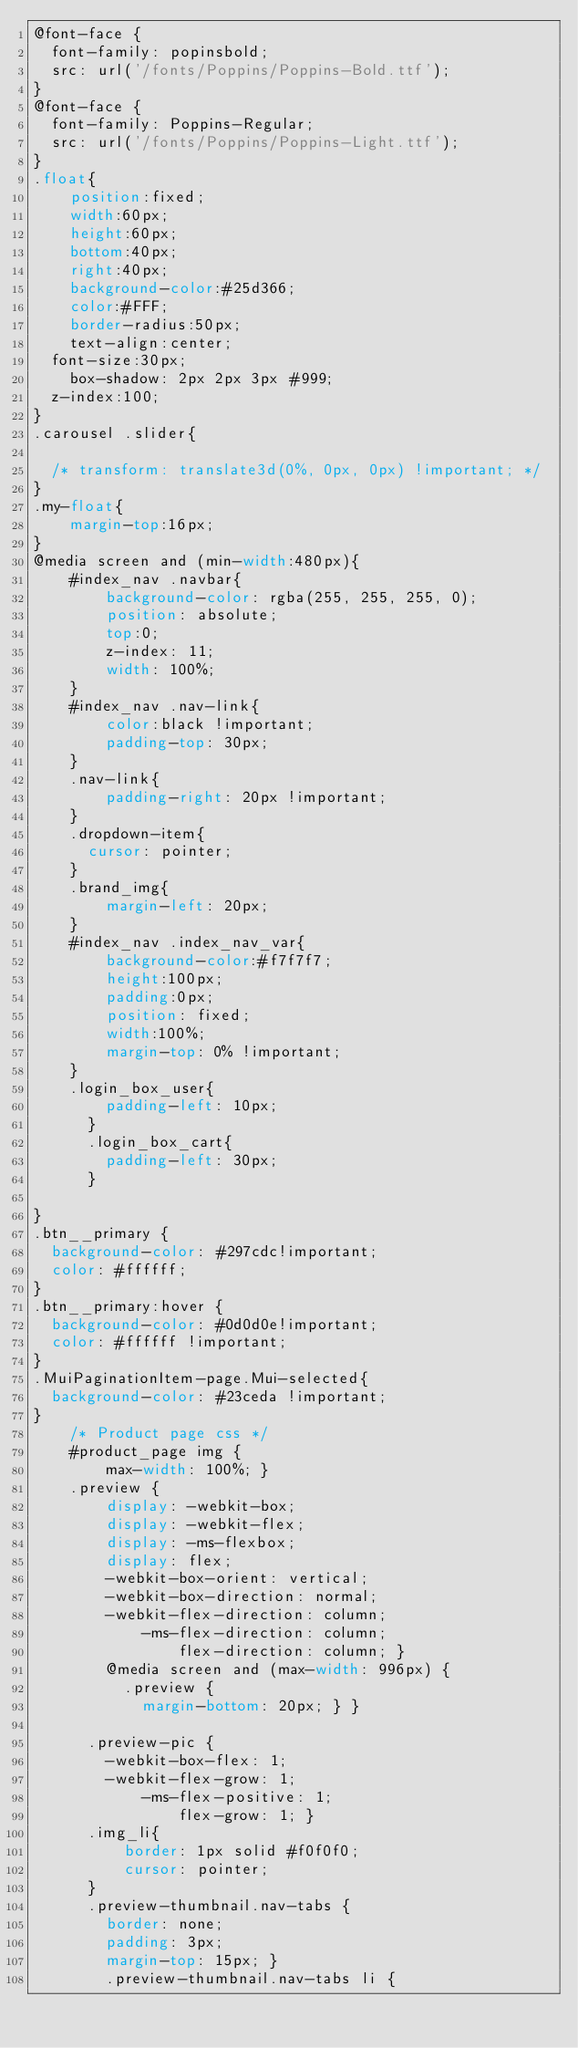Convert code to text. <code><loc_0><loc_0><loc_500><loc_500><_CSS_>@font-face {
  font-family: popinsbold;
  src: url('/fonts/Poppins/Poppins-Bold.ttf');
}
@font-face {
  font-family: Poppins-Regular;
  src: url('/fonts/Poppins/Poppins-Light.ttf');
}
.float{
	position:fixed;
	width:60px;
	height:60px;
	bottom:40px;
	right:40px;
	background-color:#25d366;
	color:#FFF;
	border-radius:50px;
	text-align:center;
  font-size:30px;
	box-shadow: 2px 2px 3px #999;
  z-index:100;
}
.carousel .slider{

  /* transform: translate3d(0%, 0px, 0px) !important; */
}
.my-float{
	margin-top:16px;
}
@media screen and (min-width:480px){
    #index_nav .navbar{
        background-color: rgba(255, 255, 255, 0);
        position: absolute;
        top:0;
        z-index: 11;
        width: 100%;
    }
    #index_nav .nav-link{
        color:black !important;
        padding-top: 30px;
    }
    .nav-link{
        padding-right: 20px !important;
    }
    .dropdown-item{
      cursor: pointer;
    }
    .brand_img{
        margin-left: 20px;
    }
    #index_nav .index_nav_var{
        background-color:#f7f7f7;
        height:100px;
        padding:0px;
        position: fixed;
        width:100%;
        margin-top: 0% !important;
    }
    .login_box_user{
        padding-left: 10px;
      }
      .login_box_cart{
        padding-left: 30px;
      }

}
.btn__primary {
  background-color: #297cdc!important;
  color: #ffffff;
}
.btn__primary:hover {
  background-color: #0d0d0e!important;
  color: #ffffff !important;
}
.MuiPaginationItem-page.Mui-selected{
  background-color: #23ceda !important;
}
    /* Product page css */
    #product_page img {
        max-width: 100%; }
    .preview {
        display: -webkit-box;
        display: -webkit-flex;
        display: -ms-flexbox;
        display: flex;
        -webkit-box-orient: vertical;
        -webkit-box-direction: normal;
        -webkit-flex-direction: column;
            -ms-flex-direction: column;
                flex-direction: column; }
        @media screen and (max-width: 996px) {
          .preview {
            margin-bottom: 20px; } }
      
      .preview-pic {
        -webkit-box-flex: 1;
        -webkit-flex-grow: 1;
            -ms-flex-positive: 1;
                flex-grow: 1; }
      .img_li{
          border: 1px solid #f0f0f0;
          cursor: pointer;
      }
      .preview-thumbnail.nav-tabs {
        border: none;
        padding: 3px;
        margin-top: 15px; }
        .preview-thumbnail.nav-tabs li {</code> 